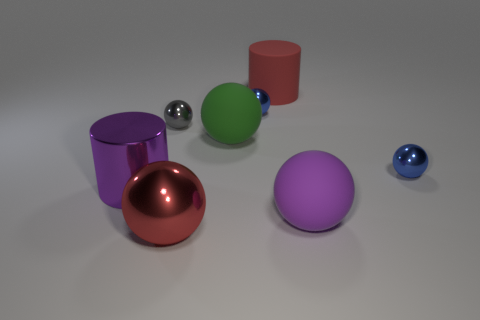Subtract all gray balls. How many balls are left? 5 Subtract 2 balls. How many balls are left? 4 Subtract all purple rubber balls. How many balls are left? 5 Subtract all cyan spheres. Subtract all brown blocks. How many spheres are left? 6 Add 1 small metal balls. How many objects exist? 9 Subtract all cylinders. How many objects are left? 6 Add 3 big metallic balls. How many big metallic balls are left? 4 Add 8 tiny purple metallic objects. How many tiny purple metallic objects exist? 8 Subtract 0 brown cylinders. How many objects are left? 8 Subtract all large gray metallic spheres. Subtract all blue shiny objects. How many objects are left? 6 